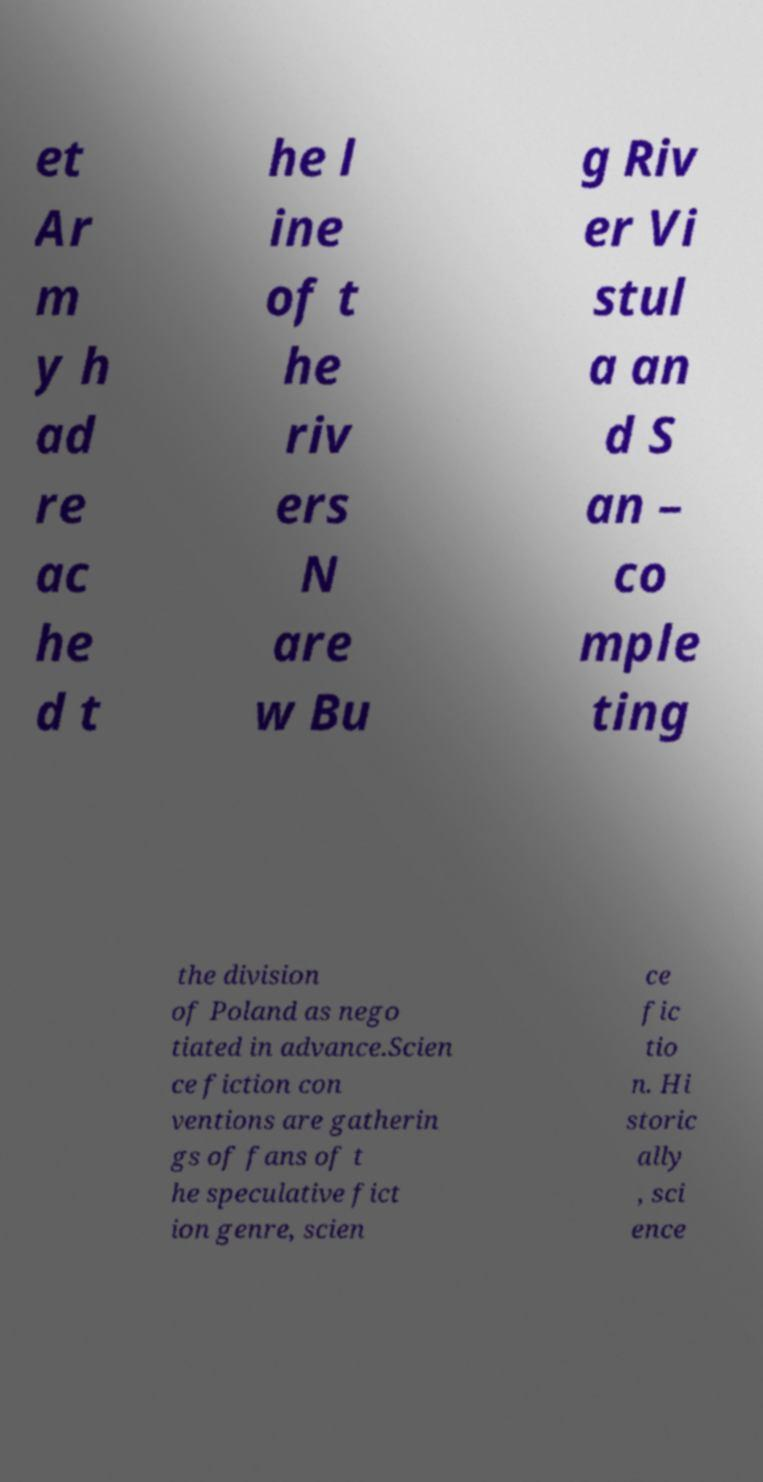Can you accurately transcribe the text from the provided image for me? et Ar m y h ad re ac he d t he l ine of t he riv ers N are w Bu g Riv er Vi stul a an d S an – co mple ting the division of Poland as nego tiated in advance.Scien ce fiction con ventions are gatherin gs of fans of t he speculative fict ion genre, scien ce fic tio n. Hi storic ally , sci ence 